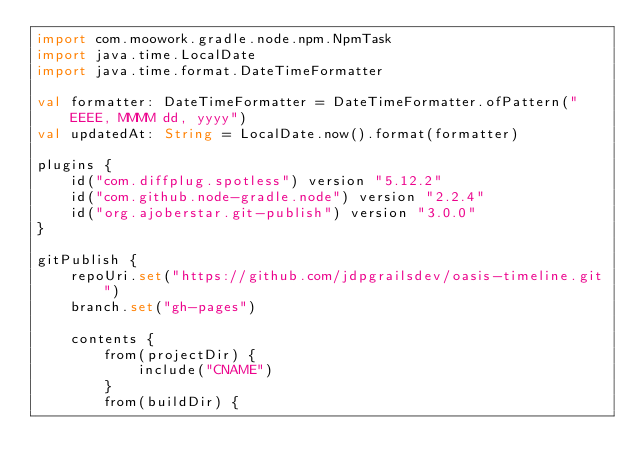<code> <loc_0><loc_0><loc_500><loc_500><_Kotlin_>import com.moowork.gradle.node.npm.NpmTask
import java.time.LocalDate
import java.time.format.DateTimeFormatter

val formatter: DateTimeFormatter = DateTimeFormatter.ofPattern("EEEE, MMMM dd, yyyy")
val updatedAt: String = LocalDate.now().format(formatter)

plugins {
    id("com.diffplug.spotless") version "5.12.2"
    id("com.github.node-gradle.node") version "2.2.4"
    id("org.ajoberstar.git-publish") version "3.0.0"
}

gitPublish {
    repoUri.set("https://github.com/jdpgrailsdev/oasis-timeline.git")
    branch.set("gh-pages")

    contents {
        from(projectDir) {
            include("CNAME")
        }
        from(buildDir) {</code> 